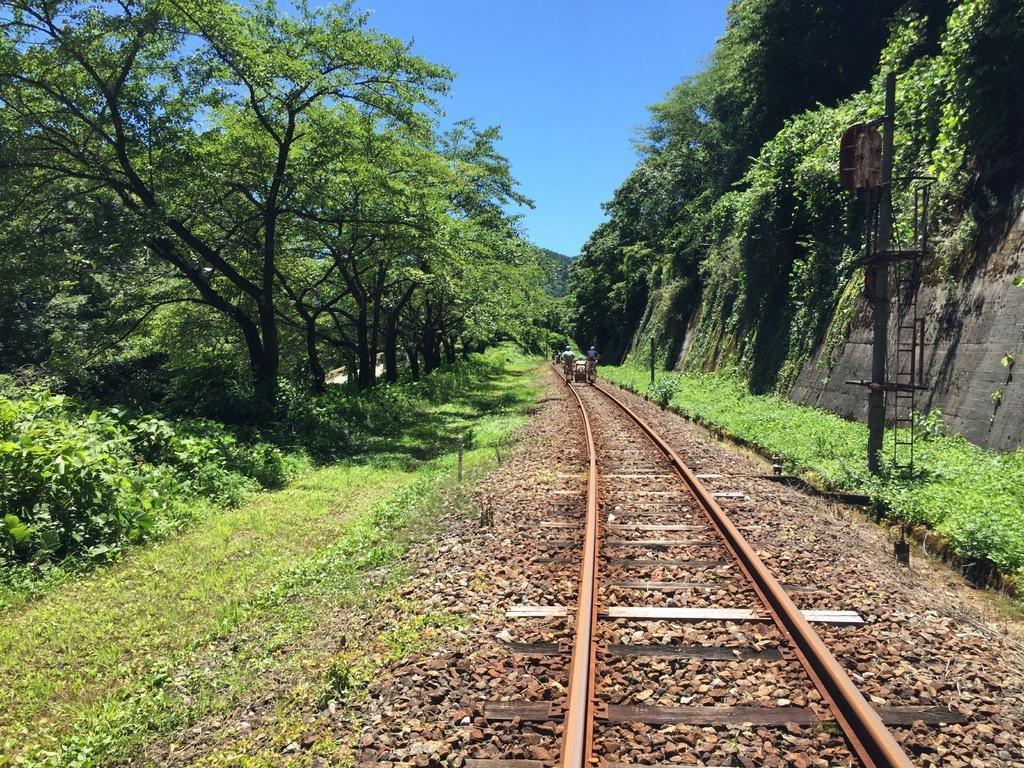Could you give a brief overview of what you see in this image? In this image we can see two persons standing on a railway track. In the background we can see pole,group of trees and sky. 